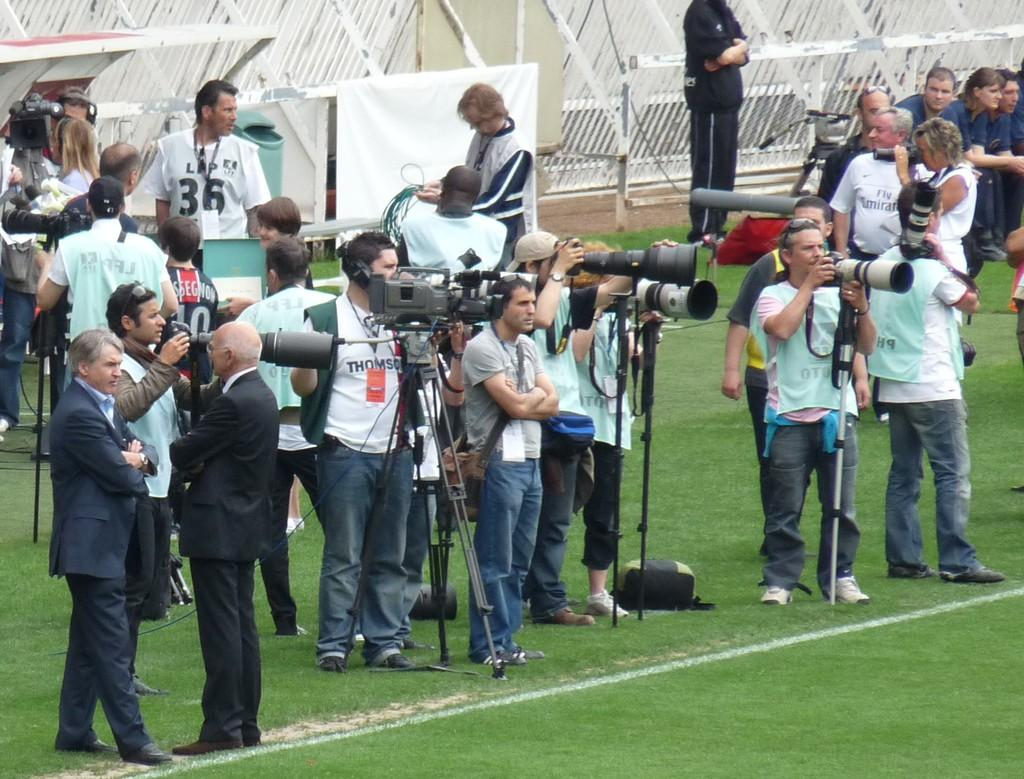What are the people in the image holding? The people in the image are holding cameras. What can be seen in the background of the image? There is a fence and people in the background of the image, as well as grass. What type of cloth is being used to protect against the sleet in the image? There is no mention of sleet or cloth in the image; it features people holding cameras with a fence and people in the background. 